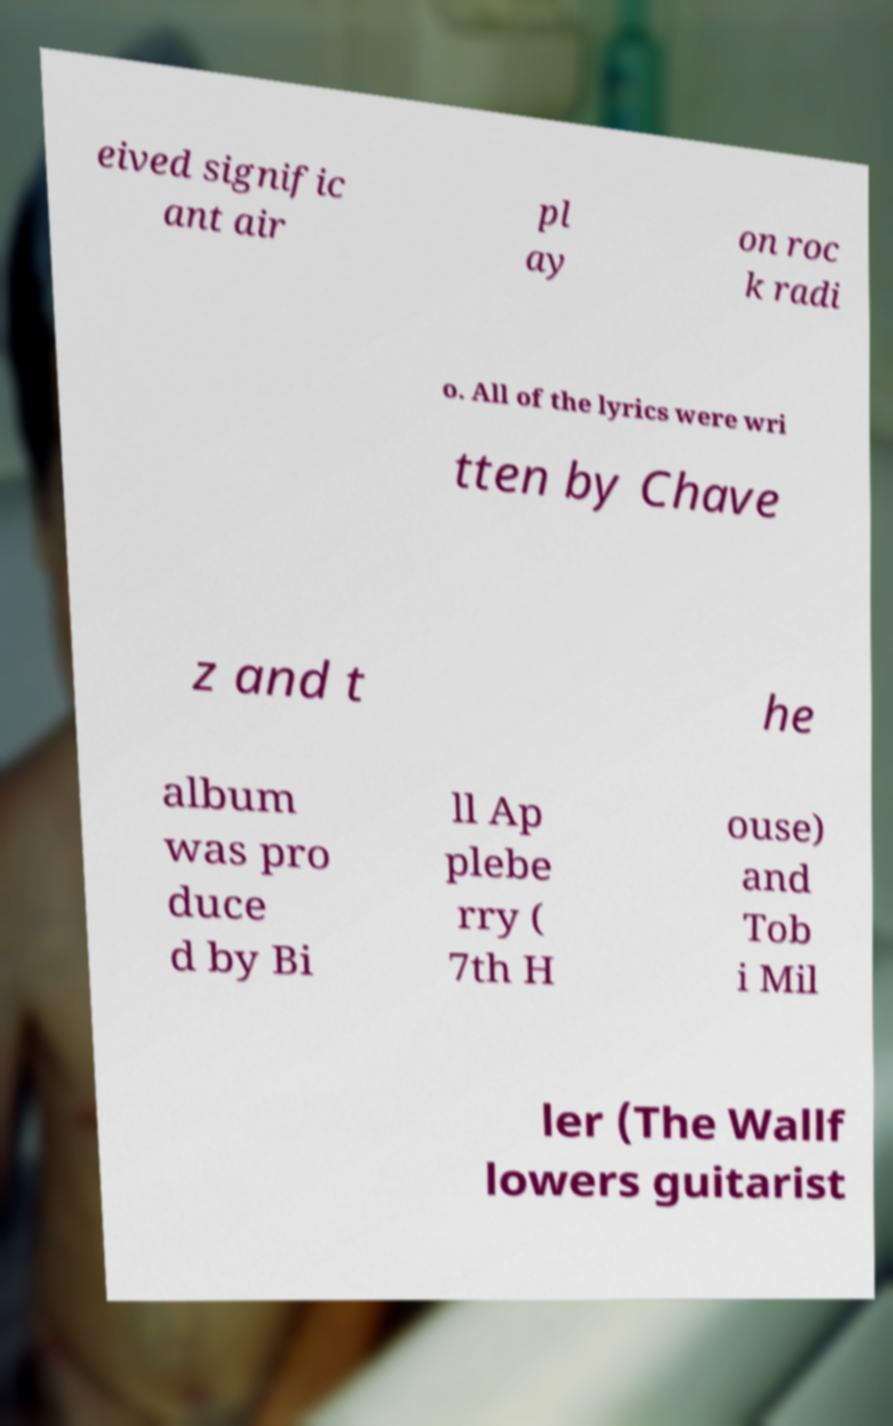Can you read and provide the text displayed in the image?This photo seems to have some interesting text. Can you extract and type it out for me? eived signific ant air pl ay on roc k radi o. All of the lyrics were wri tten by Chave z and t he album was pro duce d by Bi ll Ap plebe rry ( 7th H ouse) and Tob i Mil ler (The Wallf lowers guitarist 